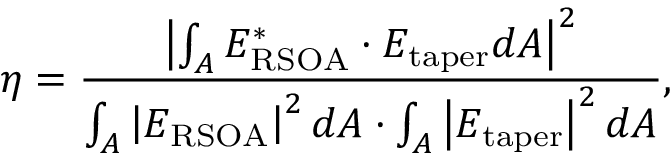Convert formula to latex. <formula><loc_0><loc_0><loc_500><loc_500>\eta = \frac { \left | \int _ { A } E _ { R S O A } ^ { * } \cdot E _ { t a p e r } d A \right | ^ { 2 } } { \int _ { A } { \left | E _ { R S O A } \right | ^ { 2 } d A \cdot \int _ { A } \left | E _ { t a p e r } \right | ^ { 2 } d A } } ,</formula> 